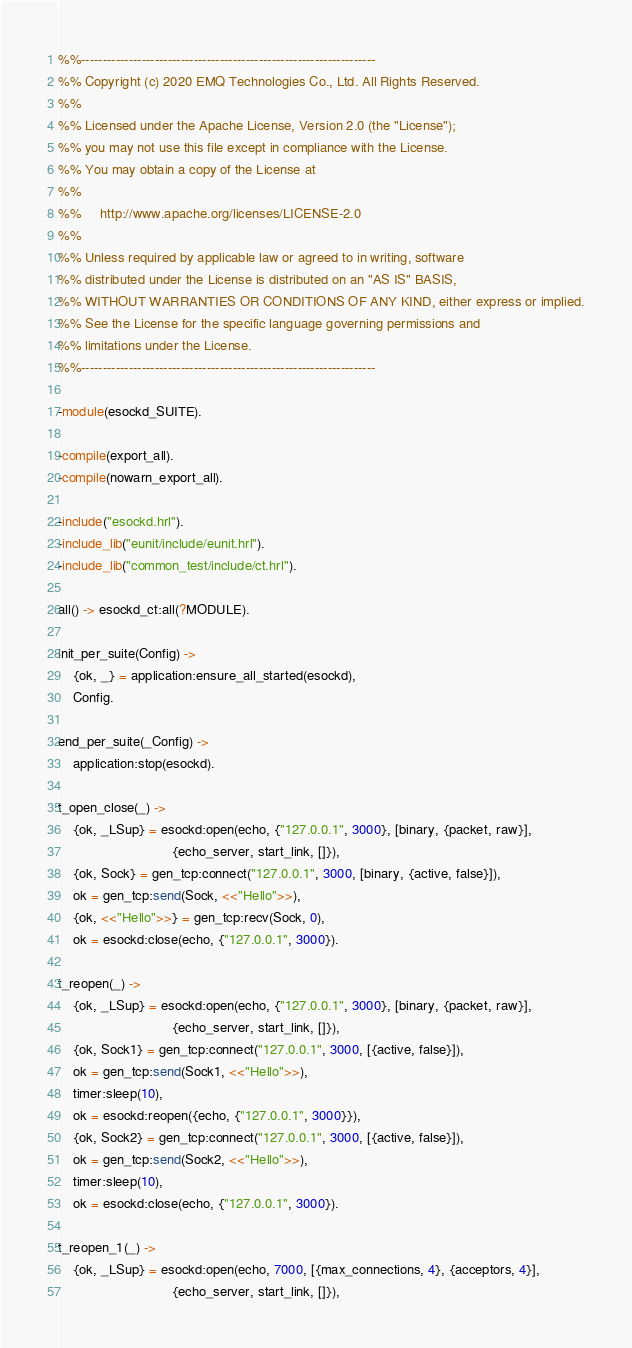<code> <loc_0><loc_0><loc_500><loc_500><_Erlang_>%%--------------------------------------------------------------------
%% Copyright (c) 2020 EMQ Technologies Co., Ltd. All Rights Reserved.
%%
%% Licensed under the Apache License, Version 2.0 (the "License");
%% you may not use this file except in compliance with the License.
%% You may obtain a copy of the License at
%%
%%     http://www.apache.org/licenses/LICENSE-2.0
%%
%% Unless required by applicable law or agreed to in writing, software
%% distributed under the License is distributed on an "AS IS" BASIS,
%% WITHOUT WARRANTIES OR CONDITIONS OF ANY KIND, either express or implied.
%% See the License for the specific language governing permissions and
%% limitations under the License.
%%--------------------------------------------------------------------

-module(esockd_SUITE).

-compile(export_all).
-compile(nowarn_export_all).

-include("esockd.hrl").
-include_lib("eunit/include/eunit.hrl").
-include_lib("common_test/include/ct.hrl").

all() -> esockd_ct:all(?MODULE).

init_per_suite(Config) ->
    {ok, _} = application:ensure_all_started(esockd),
    Config.

end_per_suite(_Config) ->
    application:stop(esockd).

t_open_close(_) ->
    {ok, _LSup} = esockd:open(echo, {"127.0.0.1", 3000}, [binary, {packet, raw}],
                              {echo_server, start_link, []}),
    {ok, Sock} = gen_tcp:connect("127.0.0.1", 3000, [binary, {active, false}]),
    ok = gen_tcp:send(Sock, <<"Hello">>),
    {ok, <<"Hello">>} = gen_tcp:recv(Sock, 0),
    ok = esockd:close(echo, {"127.0.0.1", 3000}).

t_reopen(_) ->
    {ok, _LSup} = esockd:open(echo, {"127.0.0.1", 3000}, [binary, {packet, raw}],
                              {echo_server, start_link, []}),
    {ok, Sock1} = gen_tcp:connect("127.0.0.1", 3000, [{active, false}]),
    ok = gen_tcp:send(Sock1, <<"Hello">>),
    timer:sleep(10),
    ok = esockd:reopen({echo, {"127.0.0.1", 3000}}),
    {ok, Sock2} = gen_tcp:connect("127.0.0.1", 3000, [{active, false}]),
    ok = gen_tcp:send(Sock2, <<"Hello">>),
    timer:sleep(10),
    ok = esockd:close(echo, {"127.0.0.1", 3000}).

t_reopen_1(_) ->
    {ok, _LSup} = esockd:open(echo, 7000, [{max_connections, 4}, {acceptors, 4}],
                              {echo_server, start_link, []}),</code> 